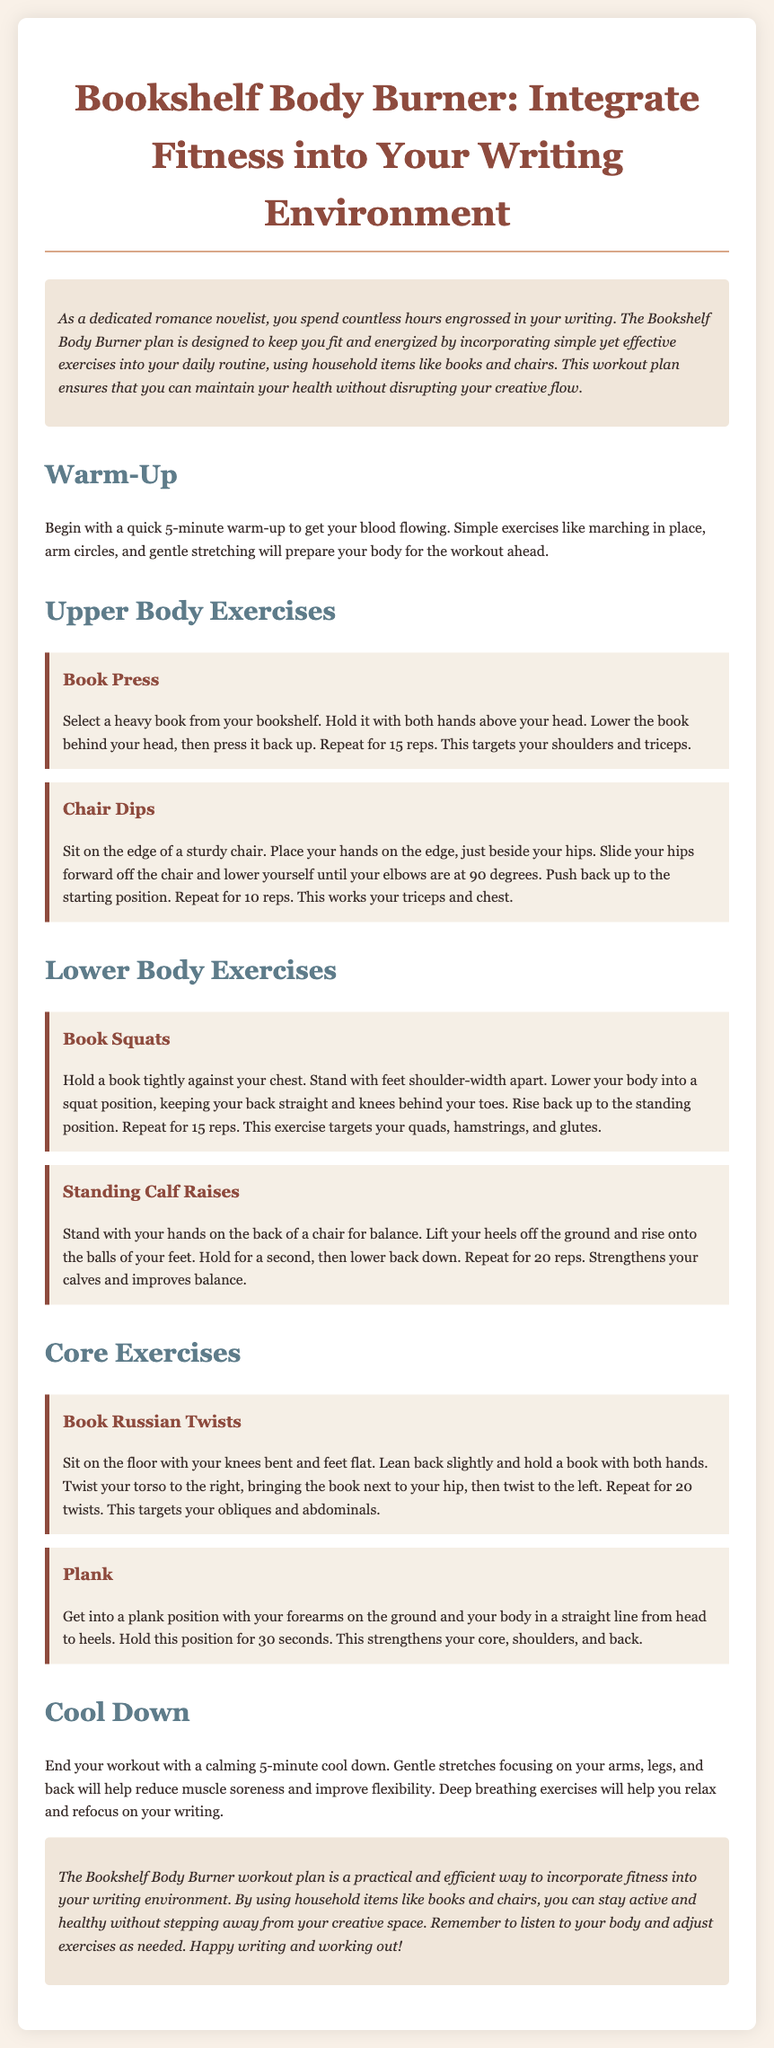What is the title of the workout plan? The title of the workout plan is prominently displayed at the top of the document.
Answer: Bookshelf Body Burner How long should the warm-up last? The document specifies a duration for the warm-up exercise section.
Answer: 5 minutes What exercise targets the shoulders and triceps? The document lists several exercises and identifies which muscle groups they target.
Answer: Book Press How many reps are suggested for Chair Dips? The number of repetitions is noted in the description of the exercise.
Answer: 10 reps What is the main focus during the cool down? The cool-down section indicates what to concentrate on after a workout.
Answer: Gentle stretches How many twists should be performed in the Book Russian Twists? The exercise section specifies how many repetitions to perform for this exercise.
Answer: 20 twists Which household item is used for Standing Calf Raises? The exercise descriptions mention specific household items that can be utilized.
Answer: Chair What strengthens your core, shoulders, and back? The document includes a specific exercise that targets these areas.
Answer: Plank What color is the background of the document? The design of the document includes a specific background color.
Answer: #f9f1e8 